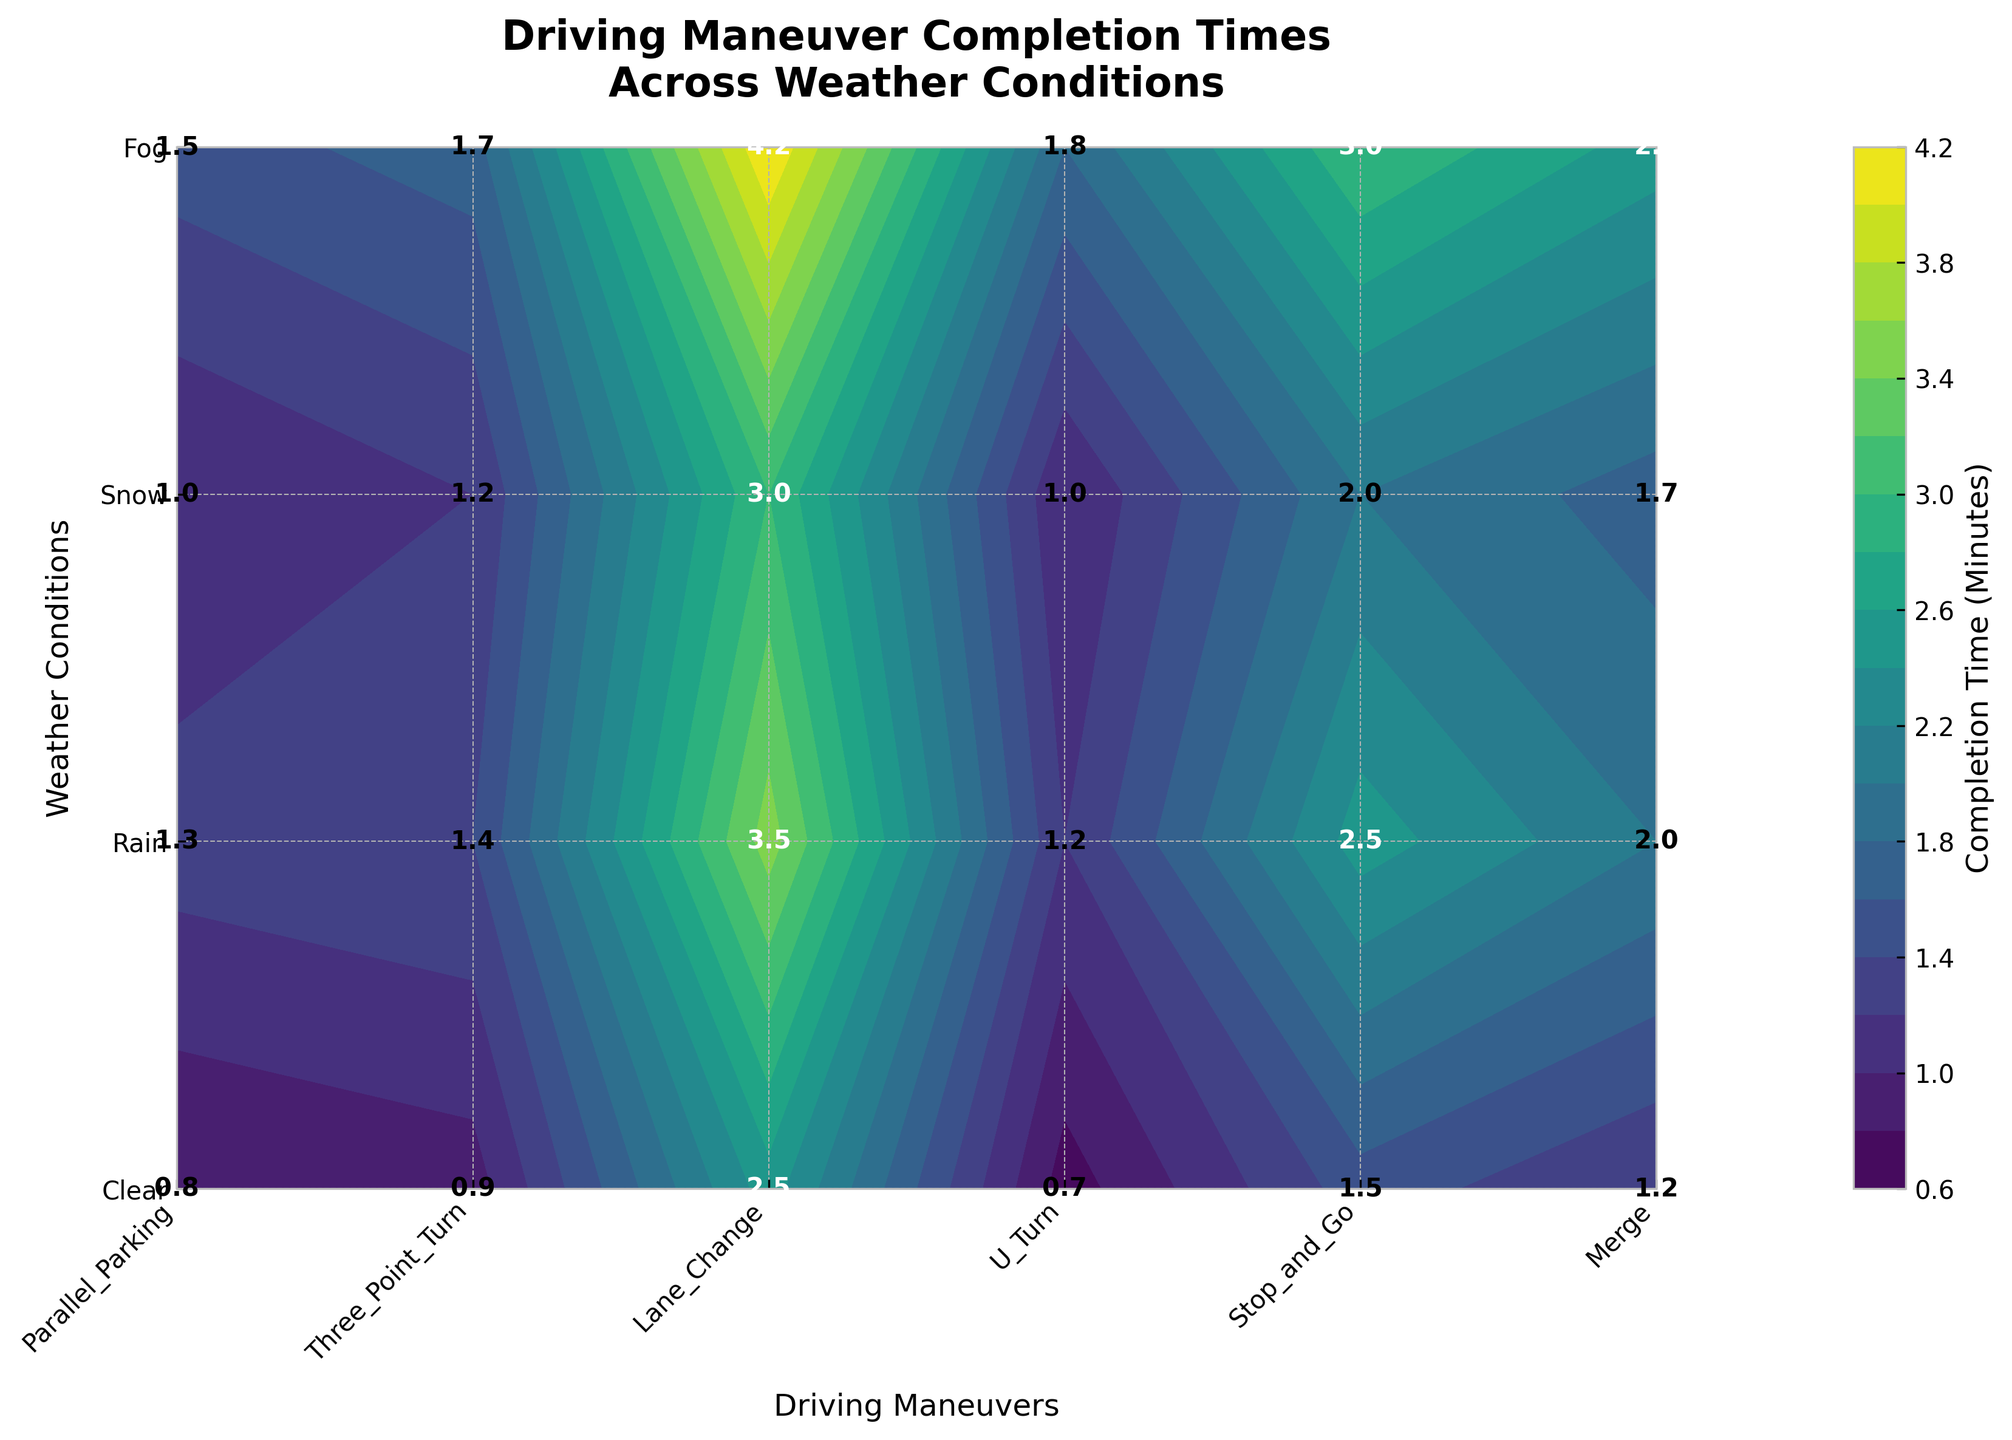What is the title of the figure? The title can be found at the top of the figure. Look at the area above the plot for a large, bold text.
Answer: Driving Maneuver Completion Times Across Weather Conditions Which driving maneuver has the shortest completion time in clear weather? Locate the x-axis where driving maneuvers are labeled, and find the corresponding position for clear weather on the y-axis. Identify the lowest value on the z-axis directly from the text annotations in the grid cells.
Answer: Stop and Go Which weather condition results in the longest completion time for Parallel Parking? Locate the y-axis where the weather conditions are labeled, then find the corresponding position for Parallel Parking on the x-axis. Identify the highest value on the z-axis directly from the text annotations in the grid cells.
Answer: Snow What is the average completion time for U-Turn in all weather conditions? Locate U-Turn on the x-axis, then note all the values for each weather condition from the y-axis. Add these values and divide by the number of weather conditions to find the average. Steps: (1.2 + 1.7 + 2.5 + 2.0) / 4 = 1.85.
Answer: 1.85 minutes Which driving maneuver takes longer in fog compared to clear weather? Check the values annotated in the grid cells for fog and clear weather conditions along the x-axis for each driving maneuver and compare. Identify the maneuvers where the fog condition value is greater. Steps: Compare each maneuver's value in fog and clear weather: Parallel Parking (3.5 > 2.5), Three-Point Turn (2.5 > 1.5), Lane Change (1.3 > 0.8), U-Turn (2.0 > 1.2), Stop and Go (1.2 > 0.7), Merge (1.4 > 0.9).
Answer: All maneuvers By how much does the completion time for Three-Point Turn in rain differ from that in fog? Find the completion times for Three-Point Turn in rain and fog from the annotations in the grid cells. Subtract the value for rain from the value for fog. Steps: Fog - Rain = 2.5 - 2.0 = 0.5.
Answer: 0.5 minutes Which weather condition generally increases the completion time across most driving maneuvers? Identify the completion times for each maneuver under all weather conditions and compare. Look for the weather condition with consistently higher values across many maneuvers.
Answer: Snow Is there any driving maneuver that has a completion time of less than 1 minute in any weather condition? Locate the annotated values in the grid cells and check for any value less than 1 minute across all weather conditions and maneuvers. Steps: Look at values under each maneuver; Lane Change (0.8), Stop and Go (0.7, Clear condition).
Answer: Yes, Stop and Go in Clear weather Which maneuver shows the least variability in completion times across different weather conditions? Calculate the range (difference between maximum and minimum values) of completion times for each maneuver across weather conditions. Steps: Parallel Parking (4.2-2.5=1.7), Three-Point Turn (3.0-1.5=1.5), Lane Change (1.5-0.8=0.7), U-Turn (2.5-1.2=1.3), Stop and Go (1.8-0.7=1.1), Merge (1.7-0.9=0.8).
Answer: Lane Change 